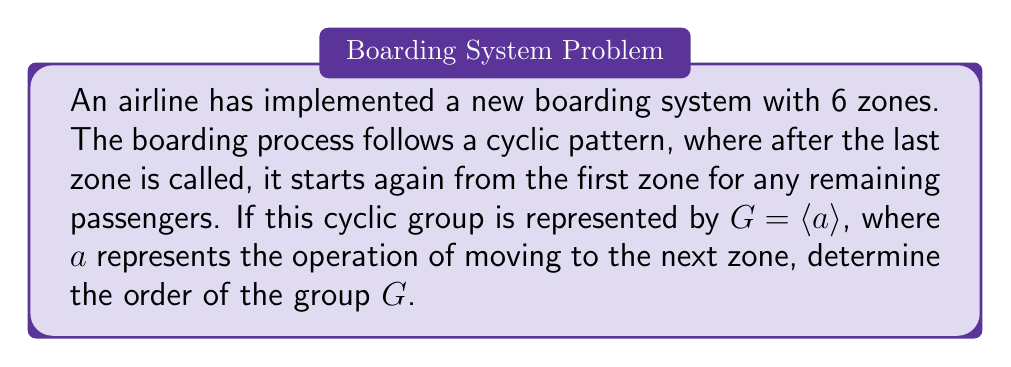Can you answer this question? To solve this problem, we need to understand the concept of cyclic groups and their orders:

1) A cyclic group is a group that can be generated by a single element, called the generator. In this case, $a$ is the generator.

2) The order of a cyclic group is the smallest positive integer $n$ such that $a^n = e$, where $e$ is the identity element.

3) In the context of our boarding zones:
   - $a$ represents moving to the next zone
   - $a^2$ represents moving two zones ahead
   - $a^3$ represents moving three zones ahead, and so on

4) Given that there are 6 zones:
   - $a^1$ moves from zone 1 to zone 2
   - $a^2$ moves from zone 1 to zone 3
   - $a^3$ moves from zone 1 to zone 4
   - $a^4$ moves from zone 1 to zone 5
   - $a^5$ moves from zone 1 to zone 6
   - $a^6$ moves from zone 1 back to zone 1

5) Therefore, $a^6 = e$, as it returns to the starting point (identity element).

6) This means that the smallest positive integer $n$ such that $a^n = e$ is 6.

Thus, the order of the cyclic group $G = \langle a \rangle$ is 6.
Answer: The order of the cyclic group $G$ representing the flight boarding zones is 6. 